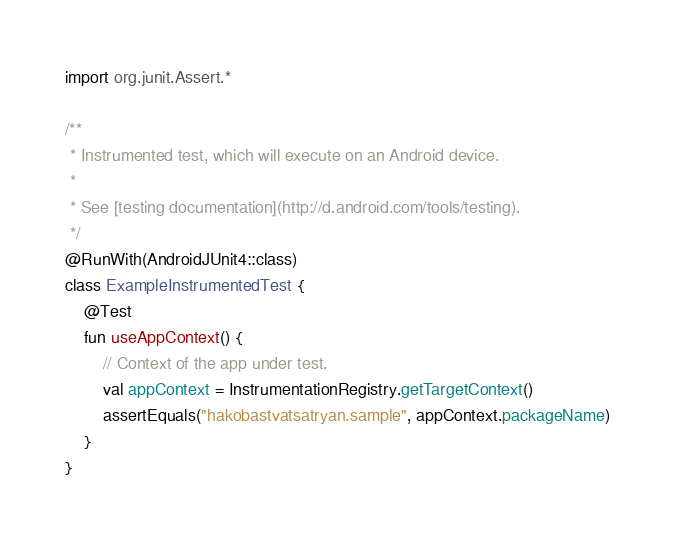Convert code to text. <code><loc_0><loc_0><loc_500><loc_500><_Kotlin_>
import org.junit.Assert.*

/**
 * Instrumented test, which will execute on an Android device.
 *
 * See [testing documentation](http://d.android.com/tools/testing).
 */
@RunWith(AndroidJUnit4::class)
class ExampleInstrumentedTest {
	@Test
	fun useAppContext() {
		// Context of the app under test.
		val appContext = InstrumentationRegistry.getTargetContext()
		assertEquals("hakobastvatsatryan.sample", appContext.packageName)
	}
}
</code> 